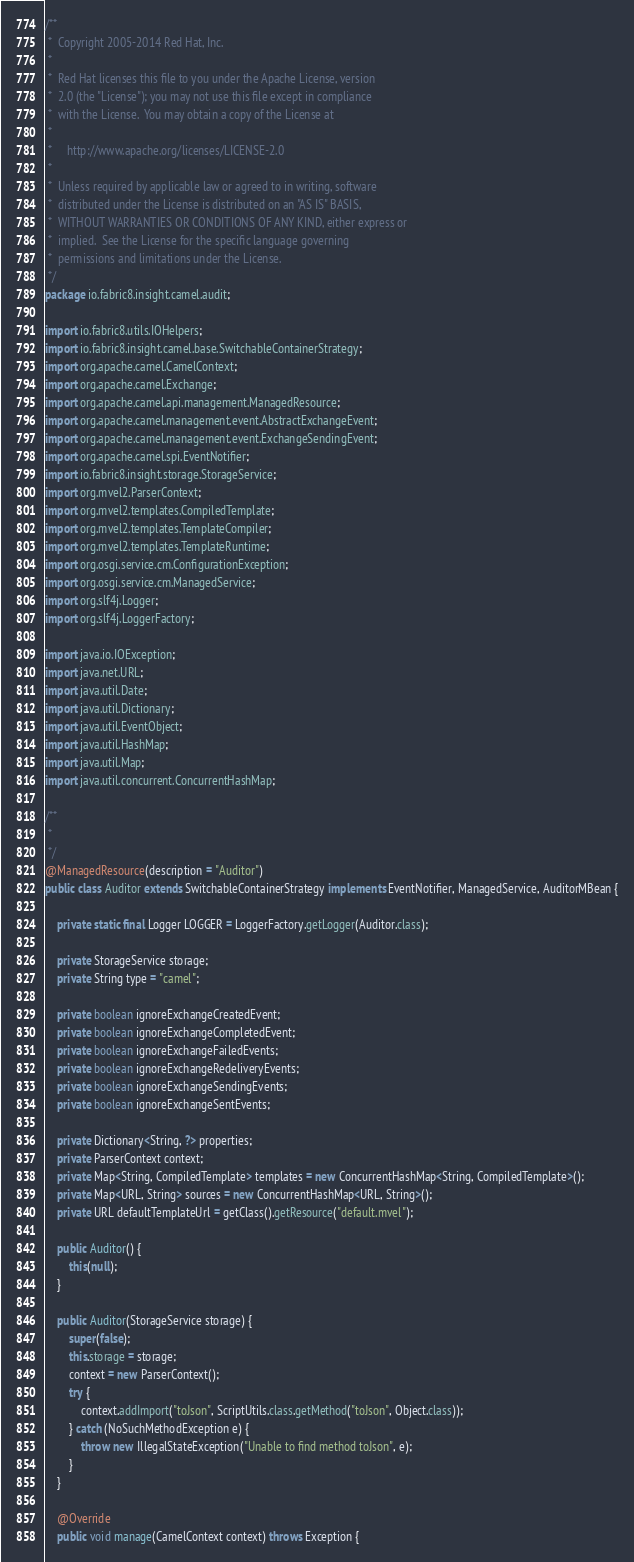Convert code to text. <code><loc_0><loc_0><loc_500><loc_500><_Java_>/**
 *  Copyright 2005-2014 Red Hat, Inc.
 *
 *  Red Hat licenses this file to you under the Apache License, version
 *  2.0 (the "License"); you may not use this file except in compliance
 *  with the License.  You may obtain a copy of the License at
 *
 *     http://www.apache.org/licenses/LICENSE-2.0
 *
 *  Unless required by applicable law or agreed to in writing, software
 *  distributed under the License is distributed on an "AS IS" BASIS,
 *  WITHOUT WARRANTIES OR CONDITIONS OF ANY KIND, either express or
 *  implied.  See the License for the specific language governing
 *  permissions and limitations under the License.
 */
package io.fabric8.insight.camel.audit;

import io.fabric8.utils.IOHelpers;
import io.fabric8.insight.camel.base.SwitchableContainerStrategy;
import org.apache.camel.CamelContext;
import org.apache.camel.Exchange;
import org.apache.camel.api.management.ManagedResource;
import org.apache.camel.management.event.AbstractExchangeEvent;
import org.apache.camel.management.event.ExchangeSendingEvent;
import org.apache.camel.spi.EventNotifier;
import io.fabric8.insight.storage.StorageService;
import org.mvel2.ParserContext;
import org.mvel2.templates.CompiledTemplate;
import org.mvel2.templates.TemplateCompiler;
import org.mvel2.templates.TemplateRuntime;
import org.osgi.service.cm.ConfigurationException;
import org.osgi.service.cm.ManagedService;
import org.slf4j.Logger;
import org.slf4j.LoggerFactory;

import java.io.IOException;
import java.net.URL;
import java.util.Date;
import java.util.Dictionary;
import java.util.EventObject;
import java.util.HashMap;
import java.util.Map;
import java.util.concurrent.ConcurrentHashMap;

/**
 *
 */
@ManagedResource(description = "Auditor")
public class Auditor extends SwitchableContainerStrategy implements EventNotifier, ManagedService, AuditorMBean {

    private static final Logger LOGGER = LoggerFactory.getLogger(Auditor.class);

    private StorageService storage;
    private String type = "camel";

    private boolean ignoreExchangeCreatedEvent;
    private boolean ignoreExchangeCompletedEvent;
    private boolean ignoreExchangeFailedEvents;
    private boolean ignoreExchangeRedeliveryEvents;
    private boolean ignoreExchangeSendingEvents;
    private boolean ignoreExchangeSentEvents;

    private Dictionary<String, ?> properties;
    private ParserContext context;
    private Map<String, CompiledTemplate> templates = new ConcurrentHashMap<String, CompiledTemplate>();
    private Map<URL, String> sources = new ConcurrentHashMap<URL, String>();
    private URL defaultTemplateUrl = getClass().getResource("default.mvel");

    public Auditor() {
        this(null);
    }

    public Auditor(StorageService storage) {
        super(false);
        this.storage = storage;
        context = new ParserContext();
        try {
            context.addImport("toJson", ScriptUtils.class.getMethod("toJson", Object.class));
        } catch (NoSuchMethodException e) {
            throw new IllegalStateException("Unable to find method toJson", e);
        }
    }

    @Override
    public void manage(CamelContext context) throws Exception {</code> 